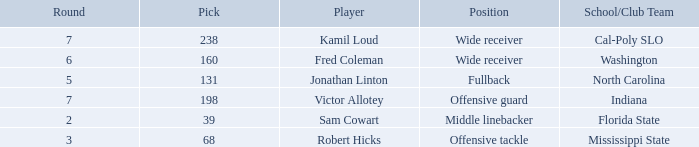Which Round has a School/Club Team of north carolina, and a Pick larger than 131? 0.0. 